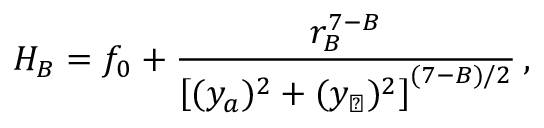Convert formula to latex. <formula><loc_0><loc_0><loc_500><loc_500>H _ { B } = f _ { 0 } + { \frac { r _ { B } ^ { 7 - B } } { \left [ ( { { y } _ { a } } ) ^ { 2 } + ( { { y } _ { \perp } } ) ^ { 2 } \right ] ^ { ( 7 - B ) / 2 } } } \, ,</formula> 